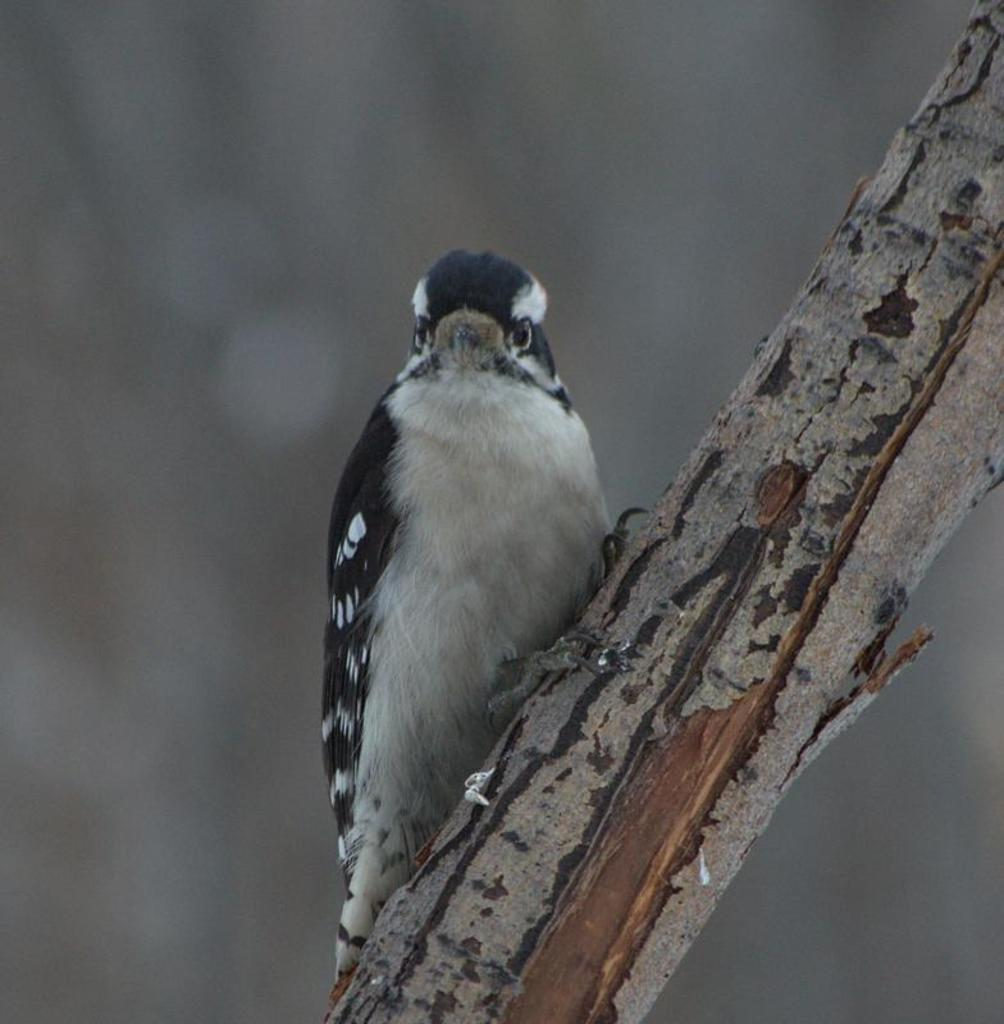What type of animal can be seen in the image? There is a bird in the image. Where is the bird positioned in relation to the tree? The bird is standing on a branch of a tree. How is the bird situated within the image? The bird is located in the center of the image. What is the weight of the spade used by the bird in the image? There is no spade present in the image, and therefore no weight can be determined. 